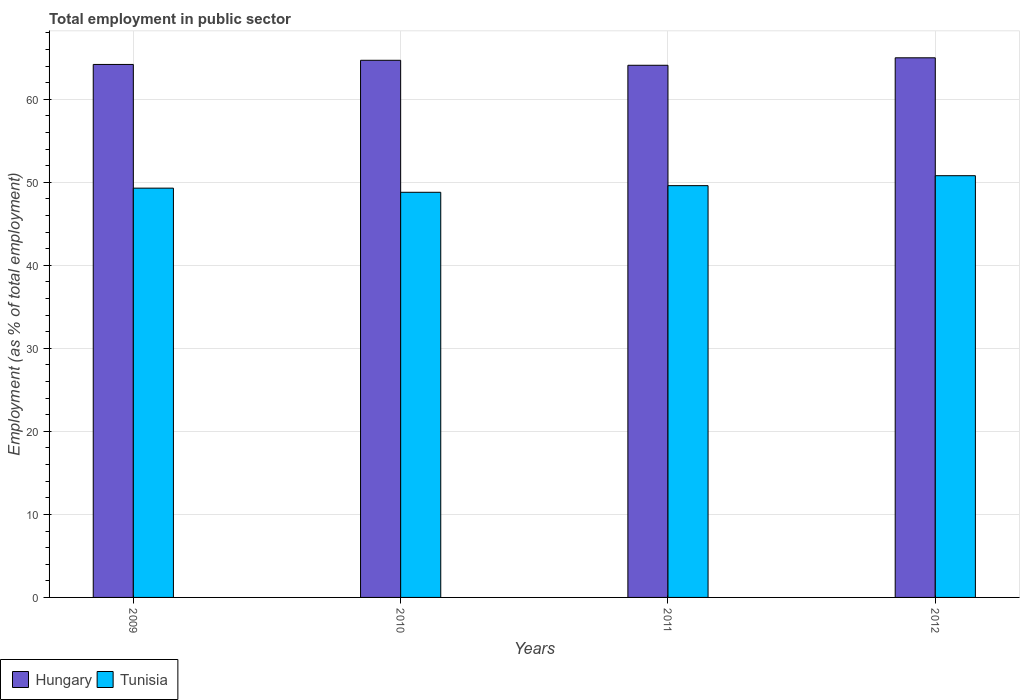How many different coloured bars are there?
Your answer should be very brief. 2. Are the number of bars per tick equal to the number of legend labels?
Your response must be concise. Yes. Are the number of bars on each tick of the X-axis equal?
Give a very brief answer. Yes. How many bars are there on the 3rd tick from the left?
Provide a succinct answer. 2. What is the employment in public sector in Tunisia in 2010?
Make the answer very short. 48.8. Across all years, what is the minimum employment in public sector in Tunisia?
Provide a short and direct response. 48.8. In which year was the employment in public sector in Hungary maximum?
Keep it short and to the point. 2012. What is the total employment in public sector in Tunisia in the graph?
Keep it short and to the point. 198.5. What is the difference between the employment in public sector in Hungary in 2009 and that in 2012?
Ensure brevity in your answer.  -0.8. What is the difference between the employment in public sector in Hungary in 2011 and the employment in public sector in Tunisia in 2012?
Offer a very short reply. 13.3. What is the average employment in public sector in Tunisia per year?
Ensure brevity in your answer.  49.62. In the year 2011, what is the difference between the employment in public sector in Hungary and employment in public sector in Tunisia?
Provide a short and direct response. 14.5. In how many years, is the employment in public sector in Hungary greater than 42 %?
Your response must be concise. 4. What is the ratio of the employment in public sector in Tunisia in 2010 to that in 2012?
Offer a terse response. 0.96. Is the employment in public sector in Tunisia in 2010 less than that in 2011?
Your response must be concise. Yes. What is the difference between the highest and the second highest employment in public sector in Hungary?
Your response must be concise. 0.3. What is the difference between the highest and the lowest employment in public sector in Hungary?
Offer a very short reply. 0.9. In how many years, is the employment in public sector in Hungary greater than the average employment in public sector in Hungary taken over all years?
Keep it short and to the point. 2. Is the sum of the employment in public sector in Tunisia in 2009 and 2010 greater than the maximum employment in public sector in Hungary across all years?
Provide a succinct answer. Yes. What does the 1st bar from the left in 2012 represents?
Keep it short and to the point. Hungary. What does the 2nd bar from the right in 2010 represents?
Your answer should be very brief. Hungary. How many bars are there?
Your answer should be very brief. 8. What is the difference between two consecutive major ticks on the Y-axis?
Provide a succinct answer. 10. Are the values on the major ticks of Y-axis written in scientific E-notation?
Offer a terse response. No. Where does the legend appear in the graph?
Provide a succinct answer. Bottom left. What is the title of the graph?
Give a very brief answer. Total employment in public sector. Does "United Kingdom" appear as one of the legend labels in the graph?
Provide a succinct answer. No. What is the label or title of the X-axis?
Provide a succinct answer. Years. What is the label or title of the Y-axis?
Ensure brevity in your answer.  Employment (as % of total employment). What is the Employment (as % of total employment) of Hungary in 2009?
Give a very brief answer. 64.2. What is the Employment (as % of total employment) of Tunisia in 2009?
Give a very brief answer. 49.3. What is the Employment (as % of total employment) in Hungary in 2010?
Your response must be concise. 64.7. What is the Employment (as % of total employment) in Tunisia in 2010?
Your answer should be very brief. 48.8. What is the Employment (as % of total employment) in Hungary in 2011?
Give a very brief answer. 64.1. What is the Employment (as % of total employment) of Tunisia in 2011?
Your answer should be compact. 49.6. What is the Employment (as % of total employment) of Tunisia in 2012?
Offer a very short reply. 50.8. Across all years, what is the maximum Employment (as % of total employment) in Tunisia?
Ensure brevity in your answer.  50.8. Across all years, what is the minimum Employment (as % of total employment) of Hungary?
Make the answer very short. 64.1. Across all years, what is the minimum Employment (as % of total employment) of Tunisia?
Give a very brief answer. 48.8. What is the total Employment (as % of total employment) of Hungary in the graph?
Offer a very short reply. 258. What is the total Employment (as % of total employment) in Tunisia in the graph?
Make the answer very short. 198.5. What is the difference between the Employment (as % of total employment) of Hungary in 2009 and that in 2010?
Ensure brevity in your answer.  -0.5. What is the difference between the Employment (as % of total employment) in Hungary in 2009 and that in 2011?
Your response must be concise. 0.1. What is the difference between the Employment (as % of total employment) in Tunisia in 2009 and that in 2012?
Offer a very short reply. -1.5. What is the difference between the Employment (as % of total employment) of Tunisia in 2010 and that in 2011?
Provide a short and direct response. -0.8. What is the difference between the Employment (as % of total employment) of Hungary in 2010 and that in 2012?
Ensure brevity in your answer.  -0.3. What is the difference between the Employment (as % of total employment) of Tunisia in 2010 and that in 2012?
Your response must be concise. -2. What is the difference between the Employment (as % of total employment) in Hungary in 2011 and that in 2012?
Ensure brevity in your answer.  -0.9. What is the difference between the Employment (as % of total employment) in Hungary in 2009 and the Employment (as % of total employment) in Tunisia in 2010?
Make the answer very short. 15.4. What is the difference between the Employment (as % of total employment) of Hungary in 2010 and the Employment (as % of total employment) of Tunisia in 2011?
Keep it short and to the point. 15.1. What is the difference between the Employment (as % of total employment) in Hungary in 2010 and the Employment (as % of total employment) in Tunisia in 2012?
Ensure brevity in your answer.  13.9. What is the difference between the Employment (as % of total employment) of Hungary in 2011 and the Employment (as % of total employment) of Tunisia in 2012?
Your response must be concise. 13.3. What is the average Employment (as % of total employment) of Hungary per year?
Make the answer very short. 64.5. What is the average Employment (as % of total employment) of Tunisia per year?
Give a very brief answer. 49.62. In the year 2011, what is the difference between the Employment (as % of total employment) in Hungary and Employment (as % of total employment) in Tunisia?
Give a very brief answer. 14.5. What is the ratio of the Employment (as % of total employment) of Tunisia in 2009 to that in 2010?
Provide a short and direct response. 1.01. What is the ratio of the Employment (as % of total employment) in Tunisia in 2009 to that in 2011?
Keep it short and to the point. 0.99. What is the ratio of the Employment (as % of total employment) of Tunisia in 2009 to that in 2012?
Offer a very short reply. 0.97. What is the ratio of the Employment (as % of total employment) of Hungary in 2010 to that in 2011?
Keep it short and to the point. 1.01. What is the ratio of the Employment (as % of total employment) in Tunisia in 2010 to that in 2011?
Your answer should be very brief. 0.98. What is the ratio of the Employment (as % of total employment) in Tunisia in 2010 to that in 2012?
Your answer should be compact. 0.96. What is the ratio of the Employment (as % of total employment) in Hungary in 2011 to that in 2012?
Provide a short and direct response. 0.99. What is the ratio of the Employment (as % of total employment) in Tunisia in 2011 to that in 2012?
Keep it short and to the point. 0.98. What is the difference between the highest and the second highest Employment (as % of total employment) in Hungary?
Offer a very short reply. 0.3. What is the difference between the highest and the lowest Employment (as % of total employment) of Tunisia?
Offer a terse response. 2. 